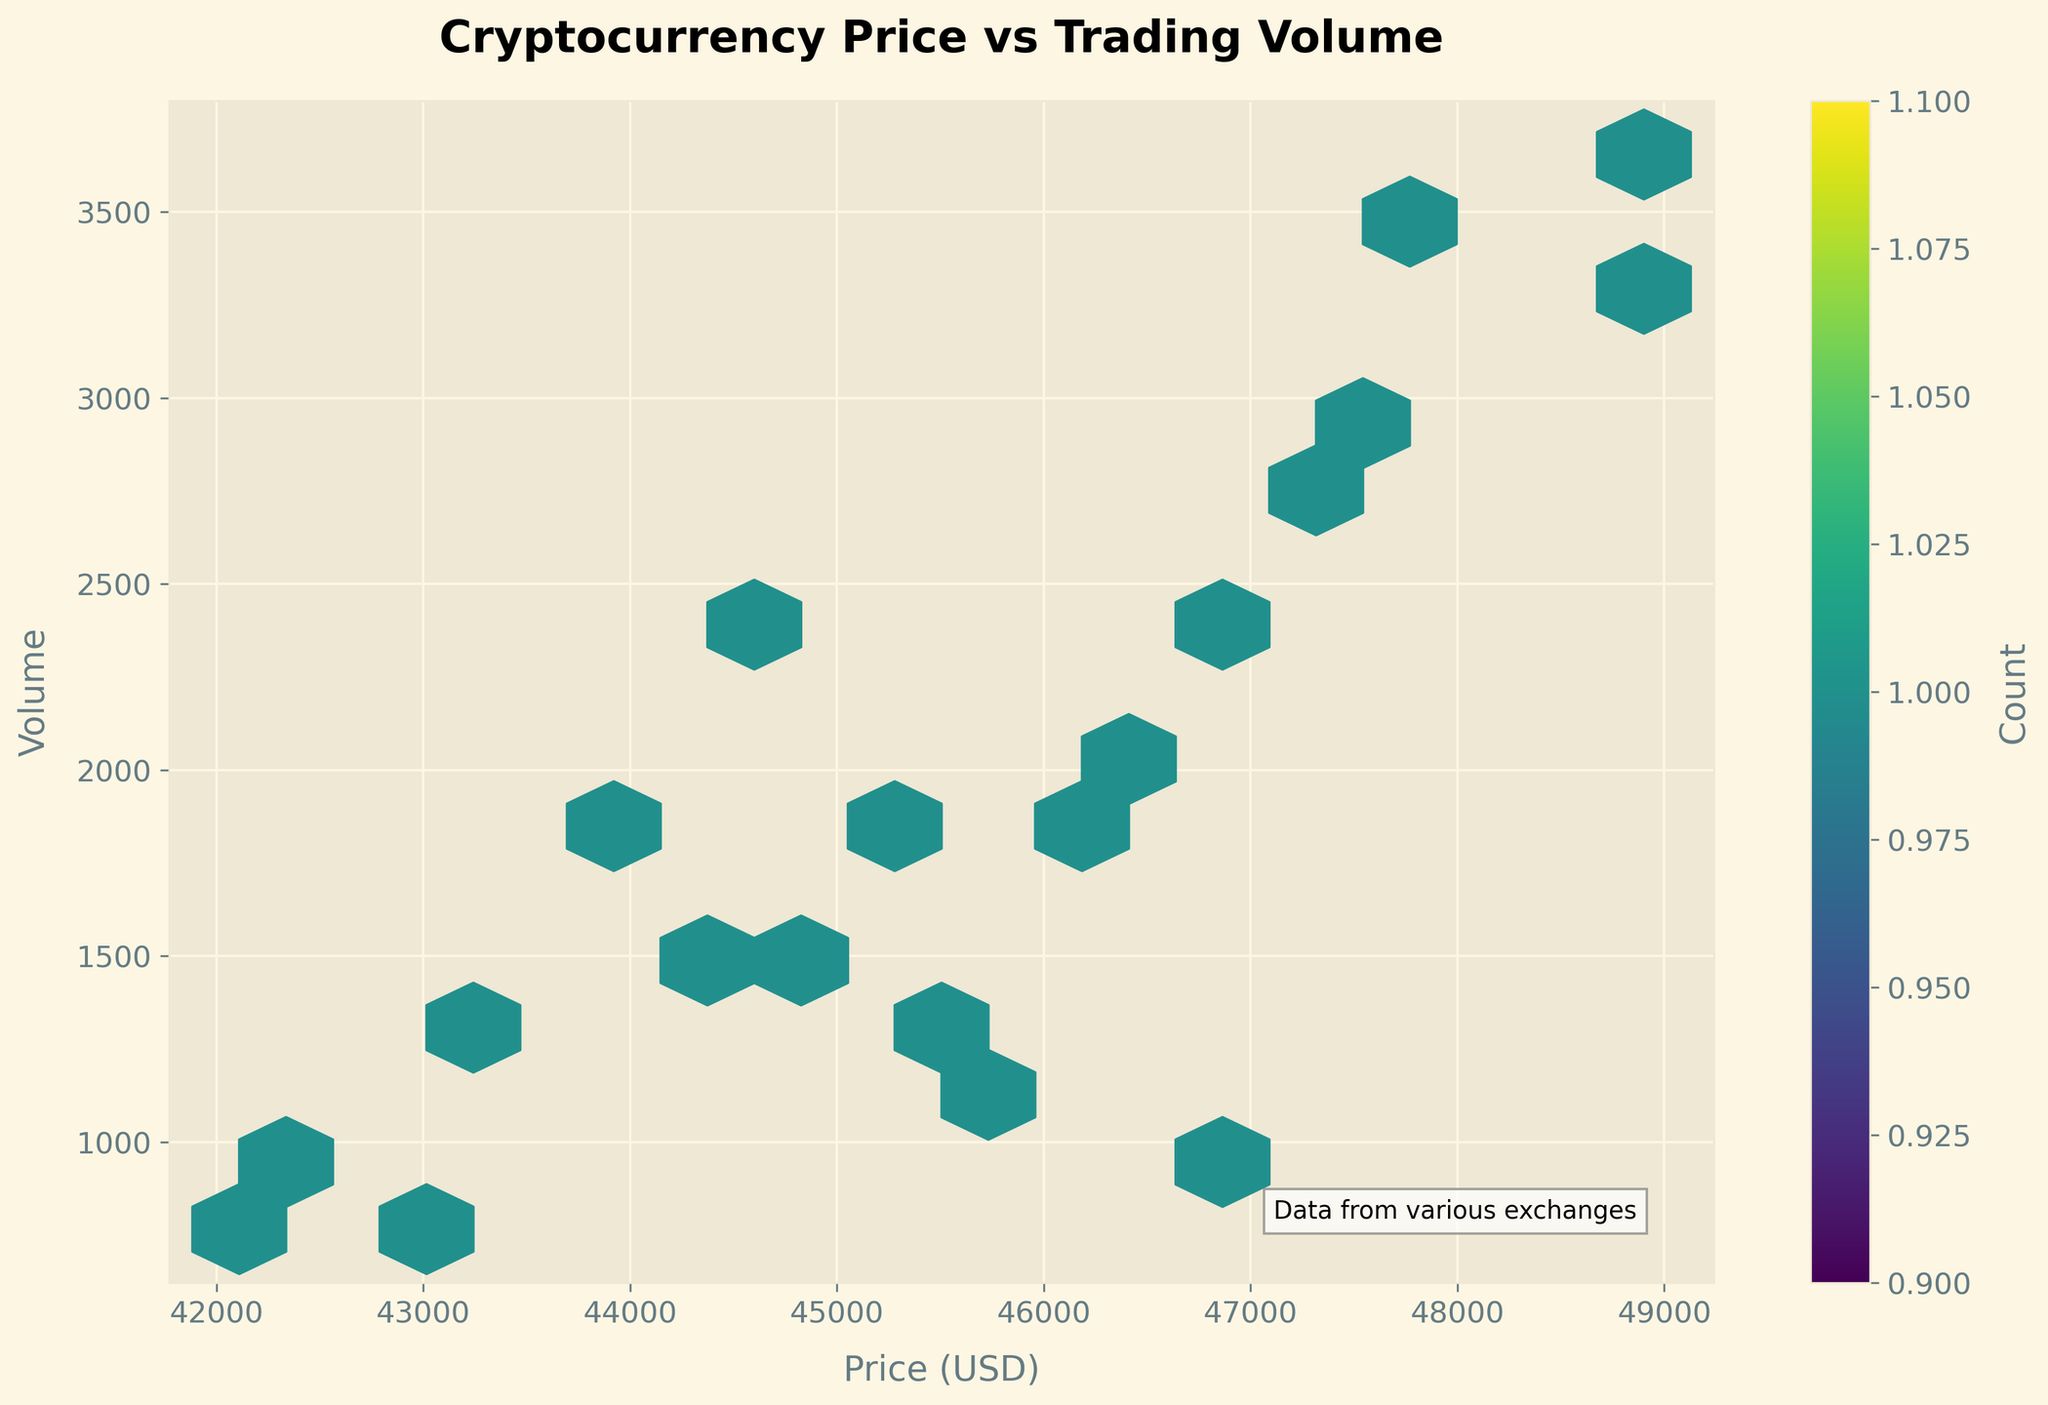What is the title of the plot? The title of the plot is shown at the top of the figure. You can see it clearly labeled there.
Answer: Cryptocurrency Price vs Trading Volume Which axis represents the price of cryptocurrencies? The x-axis represents the price of cryptocurrencies as indicated by the label below the axis that says "Price (USD)".
Answer: x-axis Which color represents the highest concentration of data points in the hexbin plot? The color bar on the right side of the plot shows the gradient of color representing concentration. The darkest to brightest yellow indicates the highest concentration.
Answer: Yellow How many bins have a count greater than 1? To determine this, observe the regions in the hexbin plot where the color is within the gradient scale. These areas indicate counts of multiple points (more than 1).
Answer: Multiple bins What is the range of trading volume displayed on the y-axis? The y-axis represents the trading volume. The range can be seen from the bottom to the top of this axis.
Answer: Approximately 765.43 to 3654.32 Which cryptocurrency exchange has the highest trading volume, and what is the corresponding trading volume? The hexbin plot does not directly label exchanges, but based on the provided data, we can identify 'Bithumb' as having the highest trading volume of 3654.32.
Answer: Bithumb, 3654.32 What is the average trading volume for the data points shown in the figure? Calculate the average by summing all trading volumes from the data and dividing by the number of data points (20). The total sum is 36987.57 and the average is 36987.57/20 ≈ 1849.38.
Answer: Approximately 1849.38 Which cryptocurrency exchange shows the lowest price, and what is the price? By referring to the dataset, the lowest price is 42109.87 from KuCoin. This value corresponds to the minimum x-values plotted on the x-axis.
Answer: KuCoin, 42109.87 How does the trading volume at Binance compare to that at Bithumb? Look at the data or refer to the volume plotted for these exchanges. Binance has a trading volume of 1234.56, while Bithumb has 3654.32, indicating Binance's volume is lower.
Answer: Lower Is there a higher concentration of data points in a specific price range? The hexbin plot highlights concentrations via color intensity. A higher concentration appears in the range of 45000 to 47000 USD.
Answer: Yes, 45000 to 47000 USD 